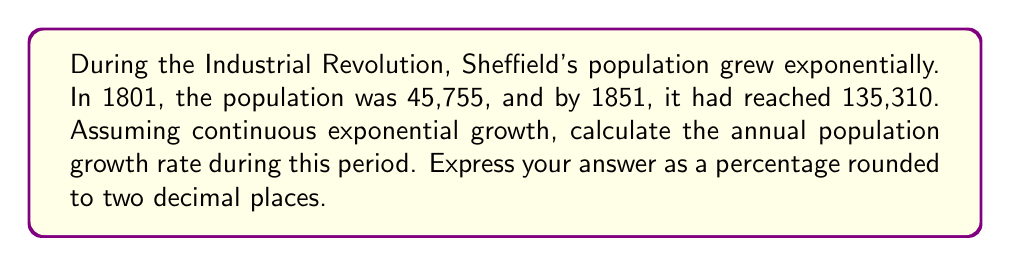Help me with this question. To solve this problem, we'll use the exponential growth formula:

$$A = P \cdot e^{rt}$$

Where:
$A$ = Final population (135,310)
$P$ = Initial population (45,755)
$r$ = Annual growth rate (what we're solving for)
$t$ = Time period in years (1851 - 1801 = 50 years)
$e$ = Euler's number (approximately 2.71828)

1. Substitute the known values into the formula:
   $$135,310 = 45,755 \cdot e^{50r}$$

2. Divide both sides by 45,755:
   $$\frac{135,310}{45,755} = e^{50r}$$

3. Take the natural logarithm of both sides:
   $$\ln\left(\frac{135,310}{45,755}\right) = 50r$$

4. Solve for $r$:
   $$r = \frac{\ln\left(\frac{135,310}{45,755}\right)}{50}$$

5. Calculate the value:
   $$r = \frac{\ln(2.9573)}{50} = \frac{1.0842}{50} = 0.021684$$

6. Convert to a percentage and round to two decimal places:
   $$0.021684 \times 100\% = 2.17\%$$
Answer: 2.17% 